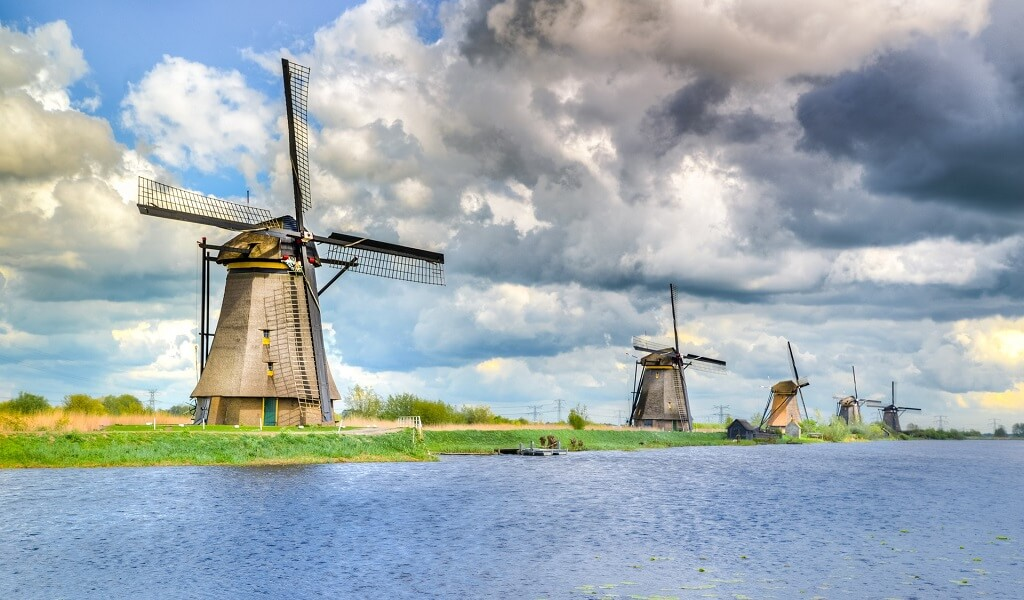Describe the following image. The image beautifully captures the iconic Kinderdijk Windmills located in the Netherlands. These historic windmills, crafted from wood and featuring the classic four-sail design, line the canal in a harmonious row. The perspective, taken from the water's edge, accentuates the towering structures as they reach towards a vibrant blue sky adorned with fluffy white clouds. The landscape is a blend of serene natural beauty and remarkable human engineering. Green grass flanks the canal, providing a vivid contrast to the earthy tones of the windmills. The serene water reflects the peaceful atmosphere, making the scene almost picturesque and idyllic. This portrayal not only highlights the architectural grandeur of the windmills but also the tranquil and timeless charm of the Dutch countryside. 